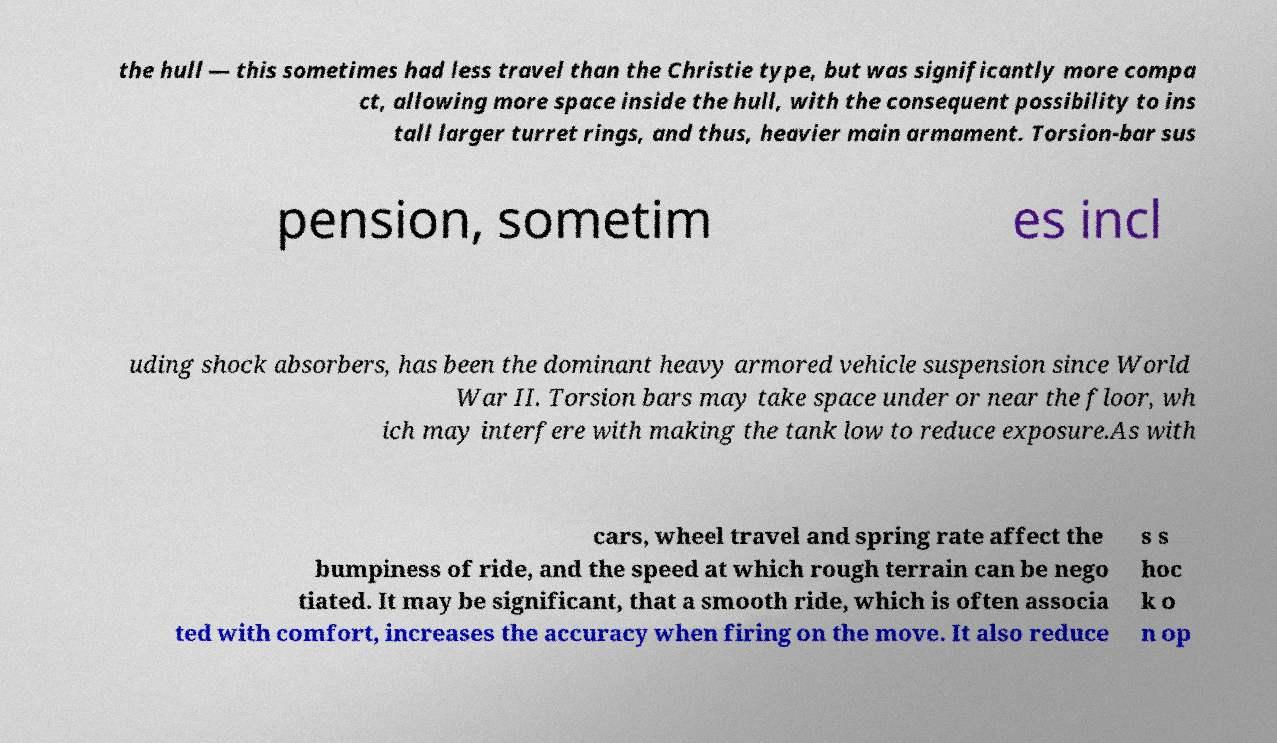For documentation purposes, I need the text within this image transcribed. Could you provide that? the hull — this sometimes had less travel than the Christie type, but was significantly more compa ct, allowing more space inside the hull, with the consequent possibility to ins tall larger turret rings, and thus, heavier main armament. Torsion-bar sus pension, sometim es incl uding shock absorbers, has been the dominant heavy armored vehicle suspension since World War II. Torsion bars may take space under or near the floor, wh ich may interfere with making the tank low to reduce exposure.As with cars, wheel travel and spring rate affect the bumpiness of ride, and the speed at which rough terrain can be nego tiated. It may be significant, that a smooth ride, which is often associa ted with comfort, increases the accuracy when firing on the move. It also reduce s s hoc k o n op 